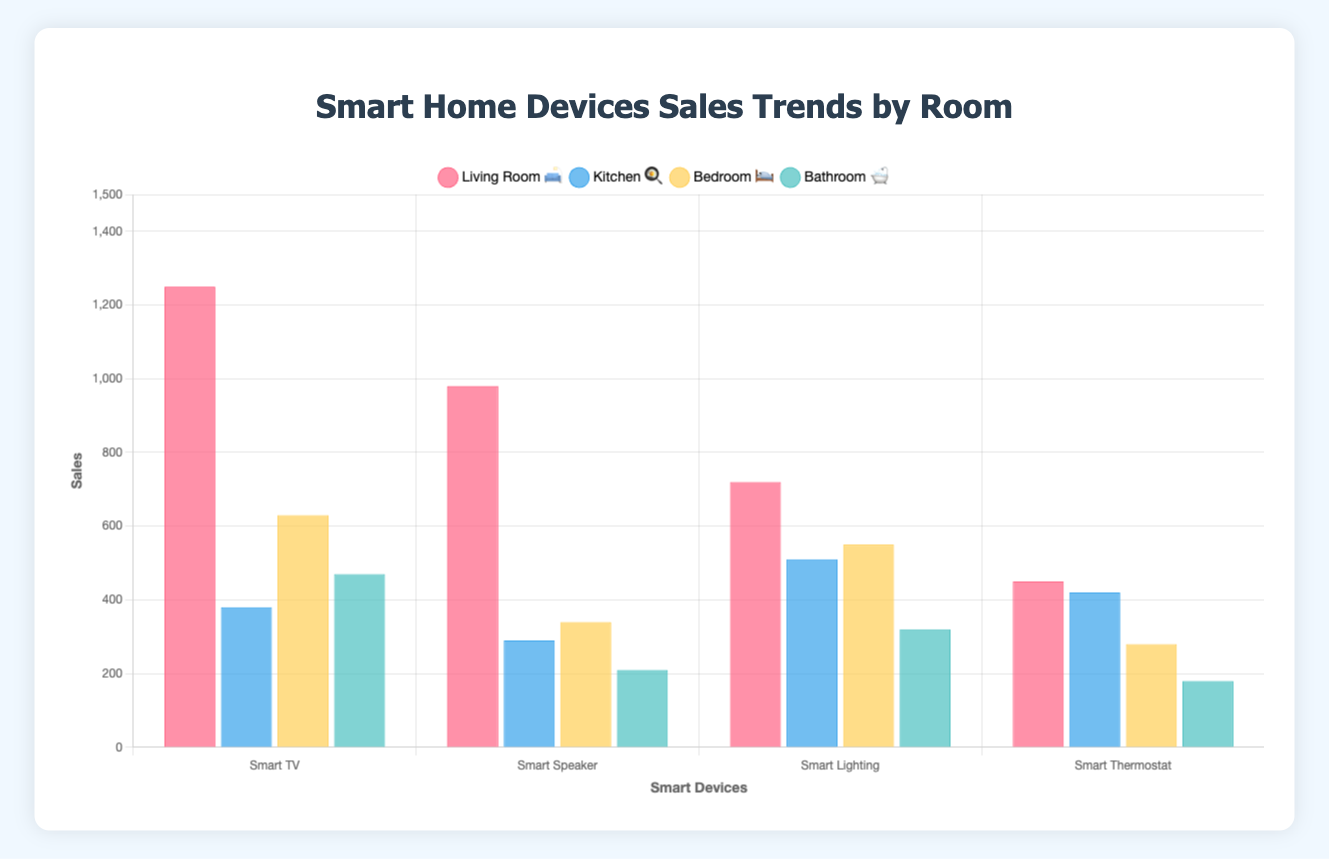What's the highest selling smart device in the Living Room 🛋️? Look at the bars for the Living Room. The "Smart TV" has the highest bar compared to other devices in the Living Room with 1250 units sold.
Answer: Smart TV What's the average sales of smart devices in the Kitchen 🍳? Sum the sales of all smart devices in the Kitchen and divide by the number of devices: (380 + 290 + 510 + 420) / 4 = 1600 / 4 = 400
Answer: 400 Which room has the least sales for any of its devices? Identify the lowest points of each room. The "Smart Shower System" in the Bathroom has the lowest sales of 180 units, lower than the lowest sales in other rooms.
Answer: Bathroom 🛁 Which room has the highest combined sales for all its devices? Combine the total sales for all devices in each room: 
- Living Room: 1250 + 980 + 720 + 450 = 3400
- Kitchen: 380 + 290 + 510 + 420 = 1600
- Bedroom: 630 + 340 + 550 + 280 = 1800
- Bathroom: 470 + 210 + 320 + 180 = 1180 
The Living Room has the highest combined sales.
Answer: Living Room 🛋️ What is the total sales of smart devices for the Bedroom 🛌? Sum the sales of all smart devices in the Bedroom: 630 + 340 + 550 + 280 = 1800
Answer: 1800 Which device in the Bathroom 🛁 has the highest sales? Look at the bars for the Bathroom. The "Smart Scale" has the highest sales with 470 units.
Answer: Smart Scale How do the sales of Smart Speakers in the Living Room 🛋️ compare to Smart Coffee Makers in the Kitchen 🍳? Compare the heights of the respective bars. The "Smart Speaker" in the Living Room has sales of 980 units, which is higher than the "Smart Coffee Maker" in the Kitchen with 510 units.
Answer: Smart Speaker (Living Room) > Smart Coffee Maker (Kitchen) What are the median sales of devices in the Living Room 🛋️? Order the sales values in the Living Room: 450, 720, 980, 1250. The two middle numbers are 720 and 980, and their average is (720 + 980) / 2 = 850.
Answer: 850 Which device has consistently similar sales across multiple rooms? Compare sales figures of specific devices across different rooms to find one with relatively consistent values. "Smart Lighting" in the Living Room has 720 sales and "Smart Display" in the Kitchen has 420 sales—a notable but not close consistency should have more specific context from chosen figures.
Answer: Not consistent enough for conclusion Is there any room where all device sales are below 500 units? Check each device's sales in all rooms:
- Living Room: all devices above 450 units.
- Kitchen: Smart Refrigerator (380), Smart Oven (290), Smart Display (420) are below 500, Smart Coffee Maker (510) above.
- Bedroom: all devices below 500.
- Bathroom: all devices below 500.
Hence, the Bathroom has all device sales below 500 units.
Answer: Bathroom 🛁 